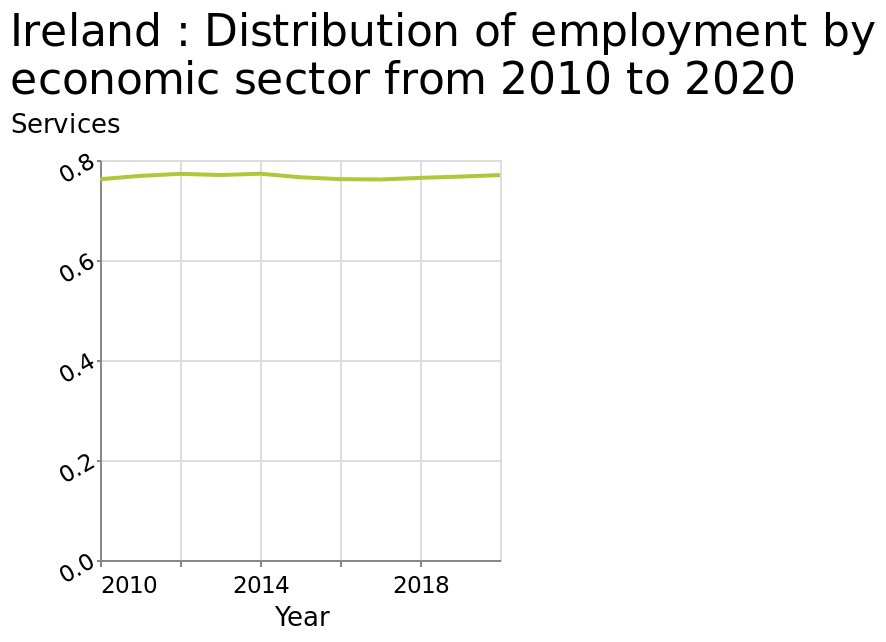<image>
What information does the line diagram depict? The line diagram depicts the distribution of employment by economic sector in Ireland from 2010 to 2020. please describe the details of the chart Ireland : Distribution of employment by economic sector from 2010 to 2020 is a line diagram. The y-axis plots Services while the x-axis measures Year. Has the employment rate in services changed significantly since 2010?  No, the employment rate in services has remained very stable since 2010, with no significant changes, at around 0.76% of employees. 